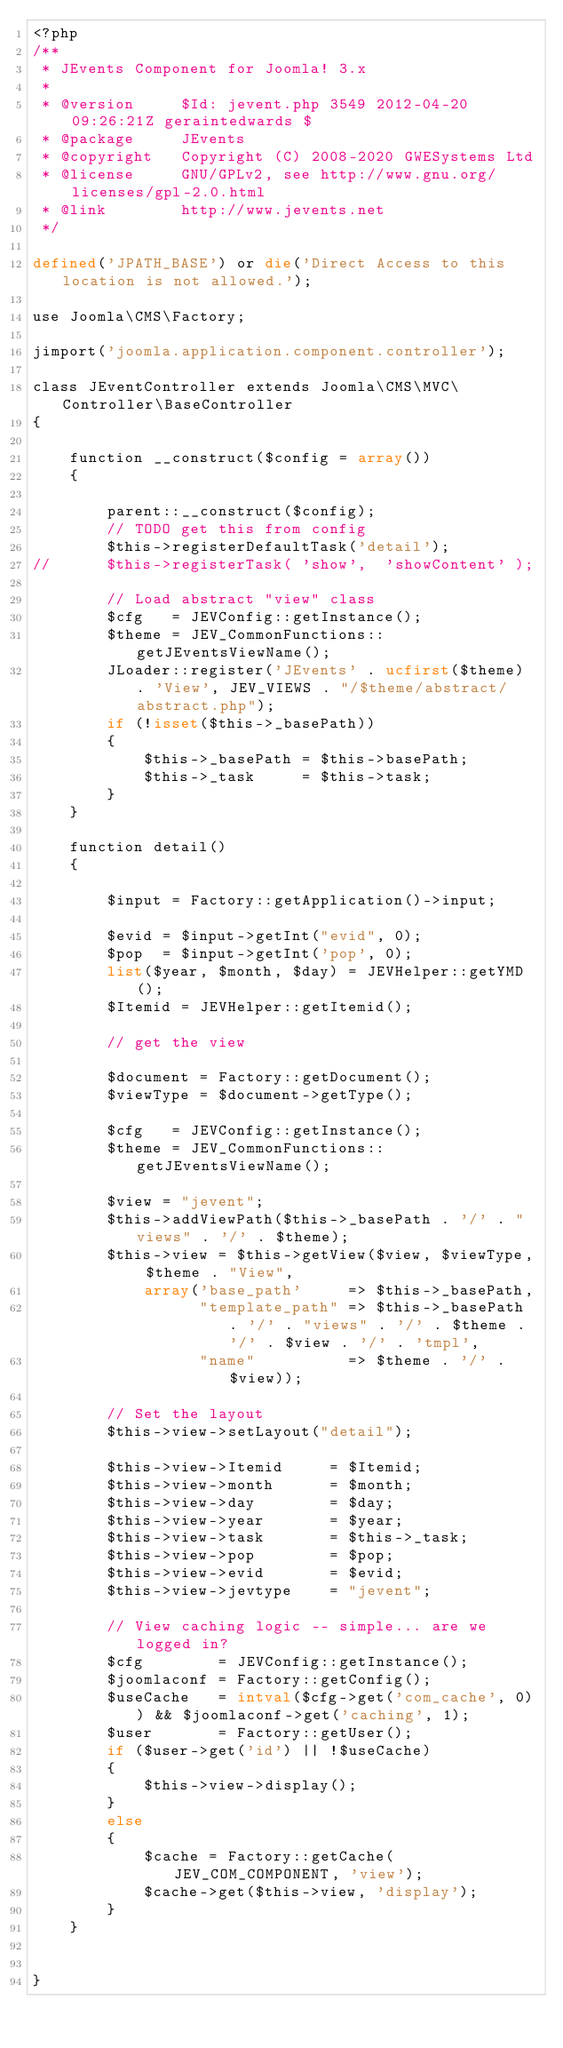Convert code to text. <code><loc_0><loc_0><loc_500><loc_500><_PHP_><?php
/**
 * JEvents Component for Joomla! 3.x
 *
 * @version     $Id: jevent.php 3549 2012-04-20 09:26:21Z geraintedwards $
 * @package     JEvents
 * @copyright   Copyright (C) 2008-2020 GWESystems Ltd
 * @license     GNU/GPLv2, see http://www.gnu.org/licenses/gpl-2.0.html
 * @link        http://www.jevents.net
 */

defined('JPATH_BASE') or die('Direct Access to this location is not allowed.');

use Joomla\CMS\Factory;

jimport('joomla.application.component.controller');

class JEventController extends Joomla\CMS\MVC\Controller\BaseController
{

	function __construct($config = array())
	{

		parent::__construct($config);
		// TODO get this from config
		$this->registerDefaultTask('detail');
//		$this->registerTask( 'show',  'showContent' );

		// Load abstract "view" class
		$cfg   = JEVConfig::getInstance();
		$theme = JEV_CommonFunctions::getJEventsViewName();
		JLoader::register('JEvents' . ucfirst($theme) . 'View', JEV_VIEWS . "/$theme/abstract/abstract.php");
		if (!isset($this->_basePath))
		{
			$this->_basePath = $this->basePath;
			$this->_task     = $this->task;
		}
	}

	function detail()
	{

		$input = Factory::getApplication()->input;

		$evid = $input->getInt("evid", 0);
		$pop  = $input->getInt('pop', 0);
		list($year, $month, $day) = JEVHelper::getYMD();
		$Itemid = JEVHelper::getItemid();

		// get the view

		$document = Factory::getDocument();
		$viewType = $document->getType();

		$cfg   = JEVConfig::getInstance();
		$theme = JEV_CommonFunctions::getJEventsViewName();

		$view = "jevent";
		$this->addViewPath($this->_basePath . '/' . "views" . '/' . $theme);
		$this->view = $this->getView($view, $viewType, $theme . "View",
			array('base_path'     => $this->_basePath,
			      "template_path" => $this->_basePath . '/' . "views" . '/' . $theme . '/' . $view . '/' . 'tmpl',
			      "name"          => $theme . '/' . $view));

		// Set the layout
		$this->view->setLayout("detail");

		$this->view->Itemid     = $Itemid;
		$this->view->month      = $month;
		$this->view->day        = $day;
		$this->view->year       = $year;
		$this->view->task       = $this->_task;
		$this->view->pop        = $pop;
		$this->view->evid       = $evid;
		$this->view->jevtype    = "jevent";

		// View caching logic -- simple... are we logged in?
		$cfg        = JEVConfig::getInstance();
		$joomlaconf = Factory::getConfig();
		$useCache   = intval($cfg->get('com_cache', 0)) && $joomlaconf->get('caching', 1);
		$user       = Factory::getUser();
		if ($user->get('id') || !$useCache)
		{
			$this->view->display();
		}
		else
		{
			$cache = Factory::getCache(JEV_COM_COMPONENT, 'view');
			$cache->get($this->view, 'display');
		}
	}


}

</code> 